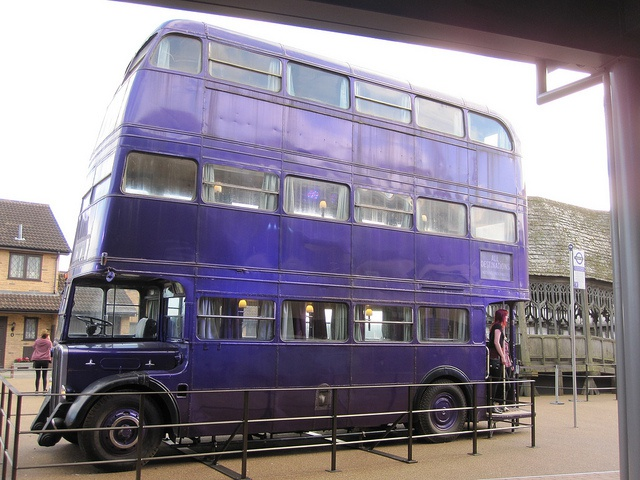Describe the objects in this image and their specific colors. I can see bus in white, black, darkgray, and navy tones, people in white, black, gray, brown, and maroon tones, people in white, black, brown, and salmon tones, and handbag in white, black, and gray tones in this image. 